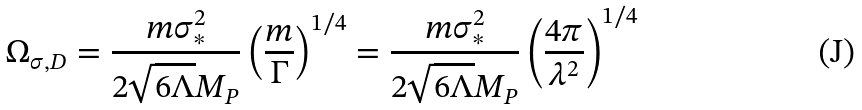Convert formula to latex. <formula><loc_0><loc_0><loc_500><loc_500>\Omega _ { \sigma , D } = \frac { m \sigma ^ { 2 } _ { \ast } } { 2 \sqrt { 6 \Lambda } M _ { P } } \left ( \frac { m } { \Gamma } \right ) ^ { 1 / 4 } = \frac { m \sigma ^ { 2 } _ { \ast } } { 2 \sqrt { 6 \Lambda } M _ { P } } \left ( \frac { 4 \pi } { \lambda ^ { 2 } } \right ) ^ { 1 / 4 }</formula> 